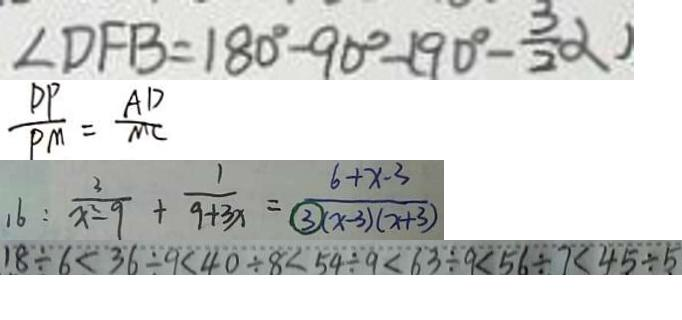Convert formula to latex. <formula><loc_0><loc_0><loc_500><loc_500>\angle D F B = 1 8 0 ^ { \circ } - 9 0 ^ { \circ } - ( 9 0 ^ { \circ } - \frac { 3 } { 2 } \alpha ) 
 \frac { D P } { P M } = \frac { A D } { M C } 
 1 6 : \frac { 3 } { x ^ { 2 } - 9 } + \frac { 1 } { 9 + 3 x } = \frac { 6 + x - 3 } { \textcircled { 3 } ( x - 3 ) ( x + 3 ) } 
 1 8 \div 6 < 3 6 \div 9 < 4 0 \div 8 < 5 4 \div 9 < 6 3 \div 9 < 5 6 \div 7 < 4 5 \div 5</formula> 